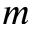<formula> <loc_0><loc_0><loc_500><loc_500>m</formula> 